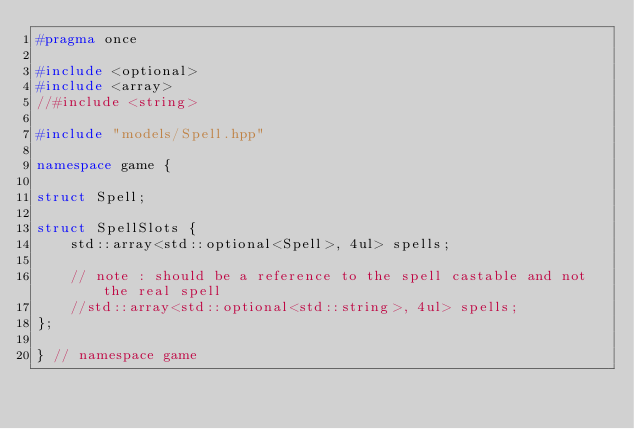<code> <loc_0><loc_0><loc_500><loc_500><_C++_>#pragma once

#include <optional>
#include <array>
//#include <string>

#include "models/Spell.hpp"

namespace game {

struct Spell;

struct SpellSlots {
    std::array<std::optional<Spell>, 4ul> spells;

    // note : should be a reference to the spell castable and not the real spell
    //std::array<std::optional<std::string>, 4ul> spells;
};

} // namespace game
</code> 